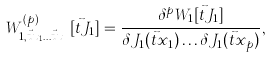<formula> <loc_0><loc_0><loc_500><loc_500>W _ { 1 , \vec { t } x _ { 1 } \dots \vec { t } x _ { p } } ^ { ( p ) } [ \vec { t } J _ { 1 } ] = \frac { \delta ^ { p } W _ { 1 } [ \vec { t } J _ { 1 } ] } { \delta J _ { 1 } ( \vec { t } x _ { 1 } ) \dots \delta J _ { 1 } ( \vec { t } x _ { p } ) } ,</formula> 